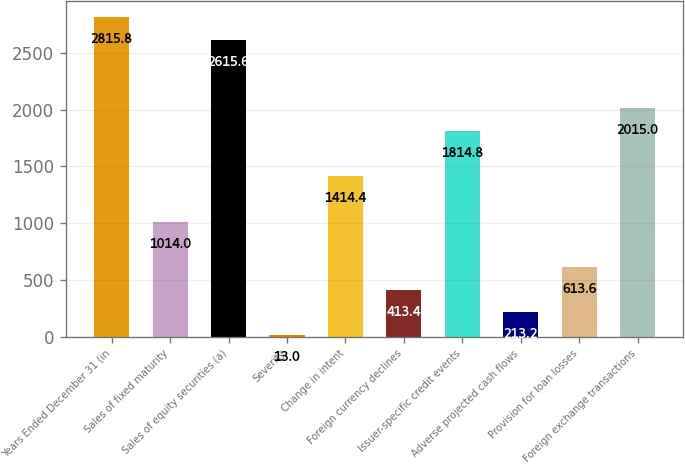Convert chart. <chart><loc_0><loc_0><loc_500><loc_500><bar_chart><fcel>Years Ended December 31 (in<fcel>Sales of fixed maturity<fcel>Sales of equity securities (a)<fcel>Severity<fcel>Change in intent<fcel>Foreign currency declines<fcel>Issuer-specific credit events<fcel>Adverse projected cash flows<fcel>Provision for loan losses<fcel>Foreign exchange transactions<nl><fcel>2815.8<fcel>1014<fcel>2615.6<fcel>13<fcel>1414.4<fcel>413.4<fcel>1814.8<fcel>213.2<fcel>613.6<fcel>2015<nl></chart> 